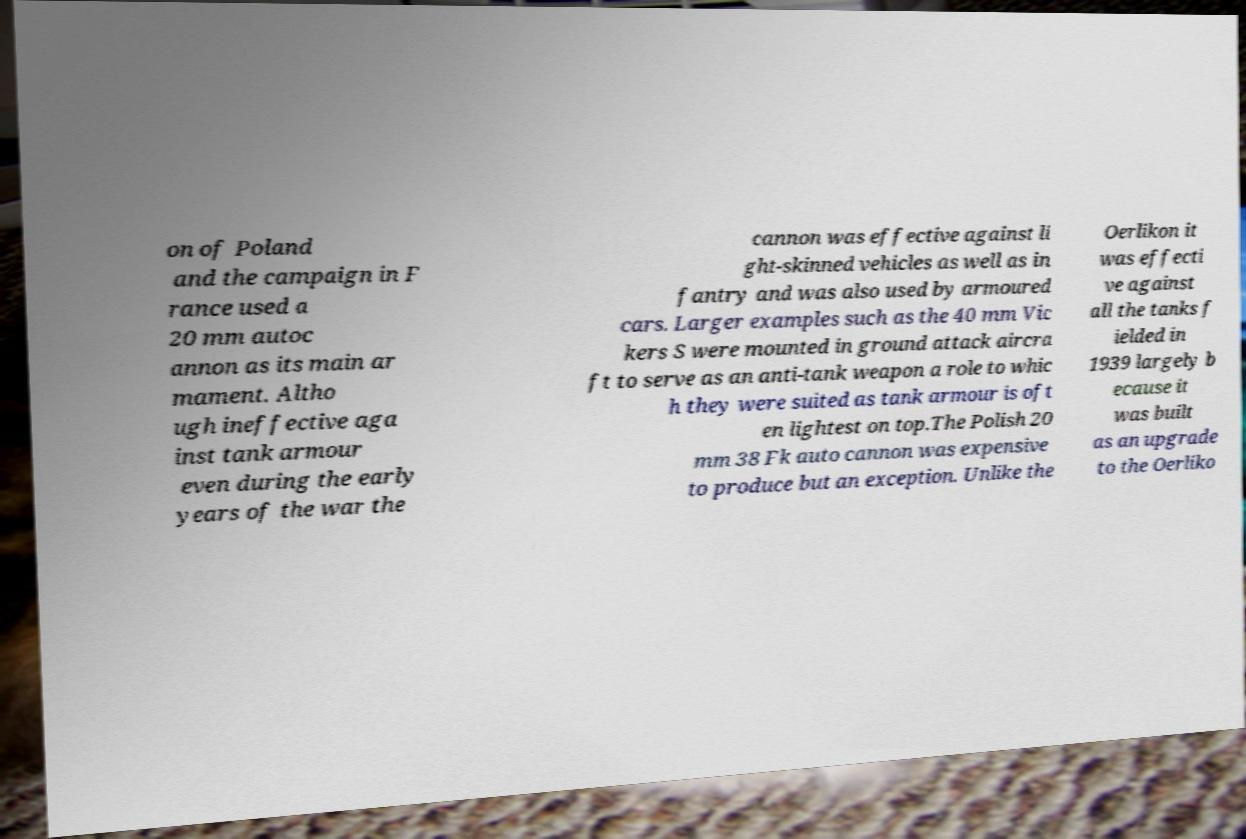Could you extract and type out the text from this image? on of Poland and the campaign in F rance used a 20 mm autoc annon as its main ar mament. Altho ugh ineffective aga inst tank armour even during the early years of the war the cannon was effective against li ght-skinned vehicles as well as in fantry and was also used by armoured cars. Larger examples such as the 40 mm Vic kers S were mounted in ground attack aircra ft to serve as an anti-tank weapon a role to whic h they were suited as tank armour is oft en lightest on top.The Polish 20 mm 38 Fk auto cannon was expensive to produce but an exception. Unlike the Oerlikon it was effecti ve against all the tanks f ielded in 1939 largely b ecause it was built as an upgrade to the Oerliko 